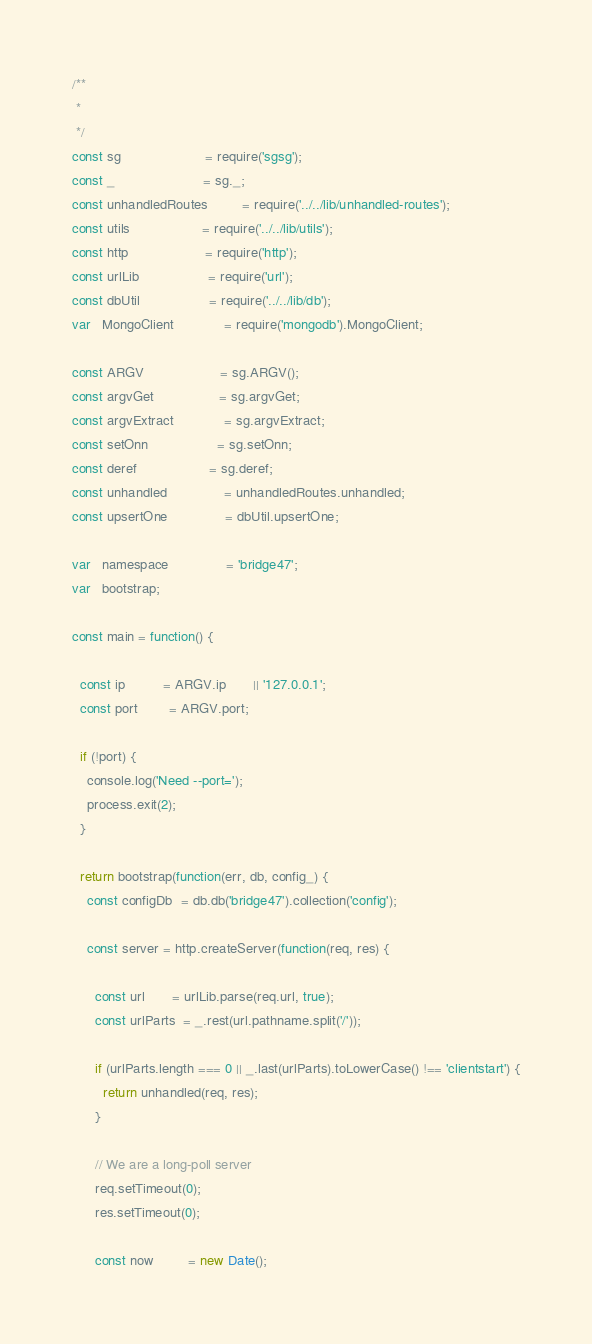<code> <loc_0><loc_0><loc_500><loc_500><_JavaScript_>
/**
 *
 */
const sg                      = require('sgsg');
const _                       = sg._;
const unhandledRoutes         = require('../../lib/unhandled-routes');
const utils                   = require('../../lib/utils');
const http                    = require('http');
const urlLib                  = require('url');
const dbUtil                  = require('../../lib/db');
var   MongoClient             = require('mongodb').MongoClient;

const ARGV                    = sg.ARGV();
const argvGet                 = sg.argvGet;
const argvExtract             = sg.argvExtract;
const setOnn                  = sg.setOnn;
const deref                   = sg.deref;
const unhandled               = unhandledRoutes.unhandled;
const upsertOne               = dbUtil.upsertOne;

var   namespace               = 'bridge47';
var   bootstrap;

const main = function() {

  const ip          = ARGV.ip       || '127.0.0.1';
  const port        = ARGV.port;

  if (!port) {
    console.log('Need --port=');
    process.exit(2);
  }

  return bootstrap(function(err, db, config_) {
    const configDb  = db.db('bridge47').collection('config');

    const server = http.createServer(function(req, res) {

      const url       = urlLib.parse(req.url, true);
      const urlParts  = _.rest(url.pathname.split('/'));

      if (urlParts.length === 0 || _.last(urlParts).toLowerCase() !== 'clientstart') {
        return unhandled(req, res);
      }

      // We are a long-poll server
      req.setTimeout(0);
      res.setTimeout(0);

      const now         = new Date();</code> 